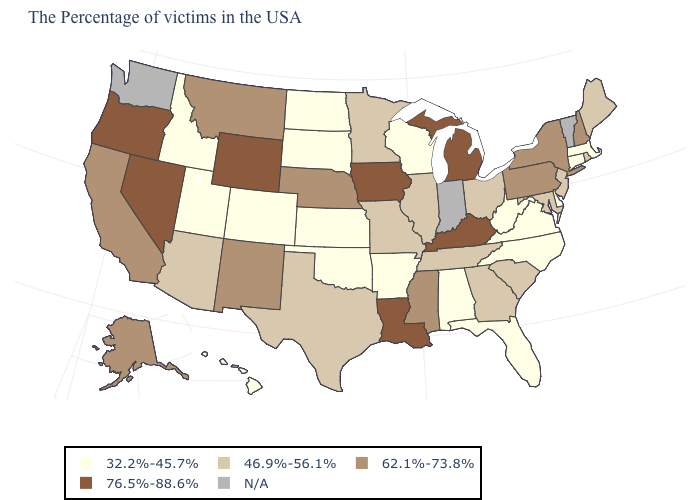Does Wisconsin have the highest value in the USA?
Answer briefly. No. Is the legend a continuous bar?
Answer briefly. No. What is the value of Maryland?
Short answer required. 46.9%-56.1%. What is the value of South Dakota?
Keep it brief. 32.2%-45.7%. Which states have the lowest value in the South?
Quick response, please. Delaware, Virginia, North Carolina, West Virginia, Florida, Alabama, Arkansas, Oklahoma. Name the states that have a value in the range 76.5%-88.6%?
Short answer required. Michigan, Kentucky, Louisiana, Iowa, Wyoming, Nevada, Oregon. Which states hav the highest value in the Northeast?
Give a very brief answer. New Hampshire, New York, Pennsylvania. Does Wisconsin have the lowest value in the USA?
Give a very brief answer. Yes. What is the highest value in states that border Florida?
Keep it brief. 46.9%-56.1%. Among the states that border Indiana , which have the highest value?
Give a very brief answer. Michigan, Kentucky. What is the value of North Dakota?
Give a very brief answer. 32.2%-45.7%. Name the states that have a value in the range N/A?
Write a very short answer. Vermont, Indiana, Washington. Name the states that have a value in the range 76.5%-88.6%?
Quick response, please. Michigan, Kentucky, Louisiana, Iowa, Wyoming, Nevada, Oregon. 